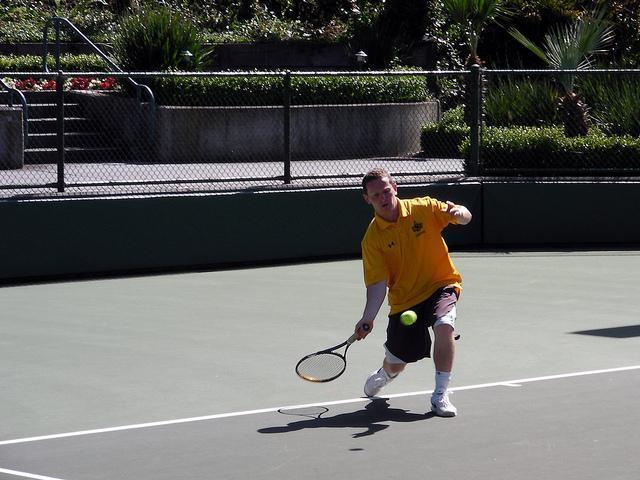How many steps are on the staircase?
Give a very brief answer. 5. 